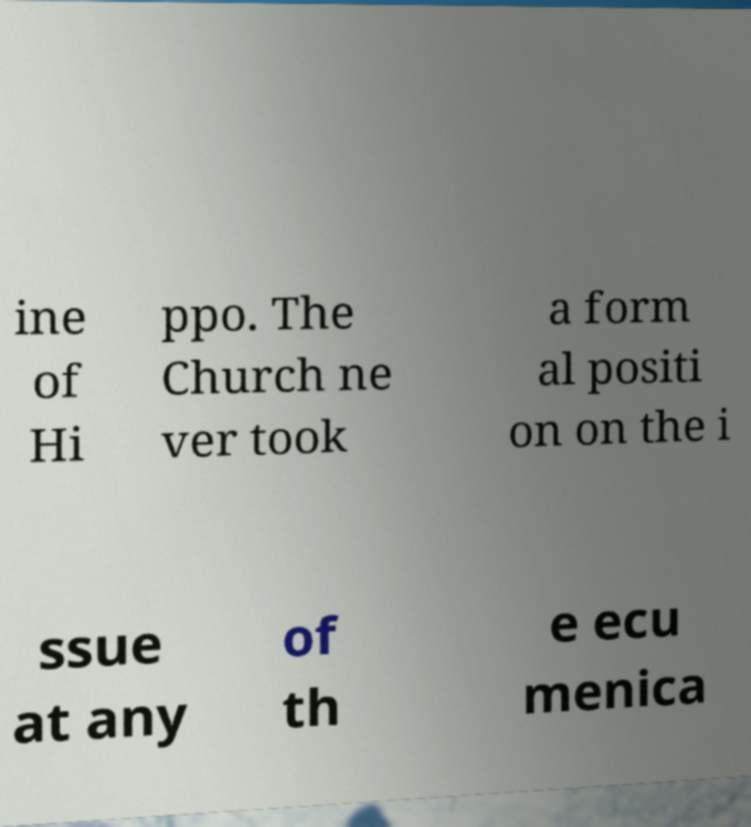There's text embedded in this image that I need extracted. Can you transcribe it verbatim? ine of Hi ppo. The Church ne ver took a form al positi on on the i ssue at any of th e ecu menica 